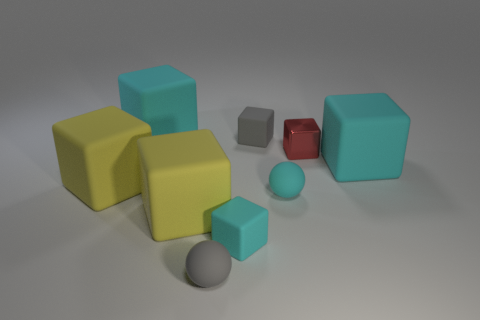Subtract all blue spheres. How many cyan cubes are left? 3 Subtract all big yellow matte blocks. How many blocks are left? 5 Subtract 4 cubes. How many cubes are left? 3 Subtract all gray blocks. How many blocks are left? 6 Subtract all blue cubes. Subtract all red spheres. How many cubes are left? 7 Add 1 yellow things. How many objects exist? 10 Subtract all balls. How many objects are left? 7 Add 8 gray rubber objects. How many gray rubber objects are left? 10 Add 6 small gray matte balls. How many small gray matte balls exist? 7 Subtract 1 gray cubes. How many objects are left? 8 